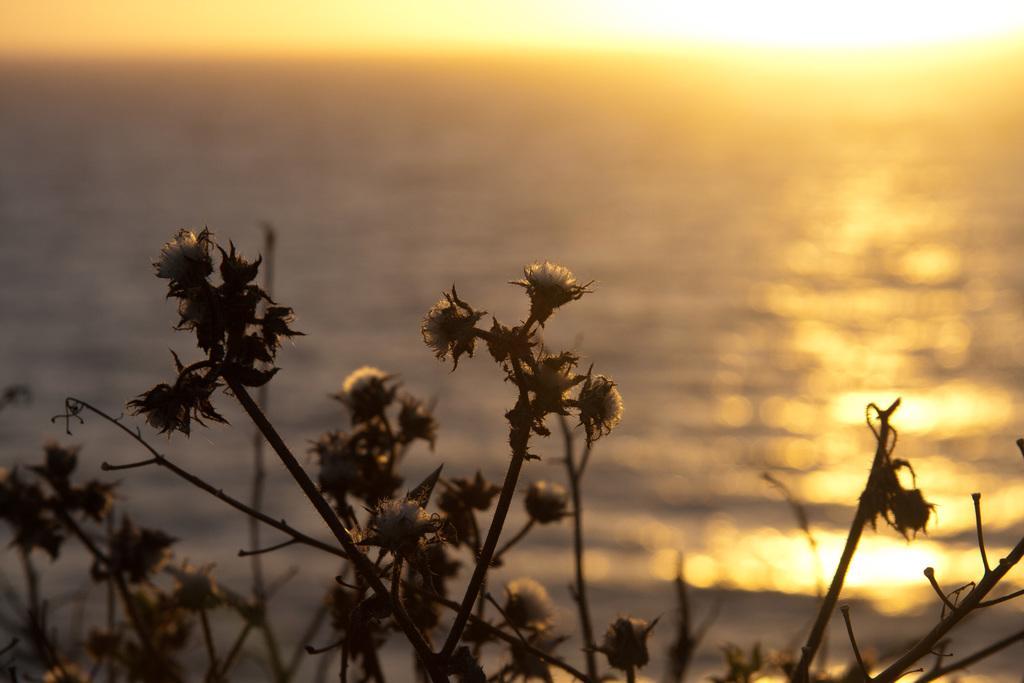Please provide a concise description of this image. In this image I can see few plants, background I can see the water and the sky is in white and yellow color. 